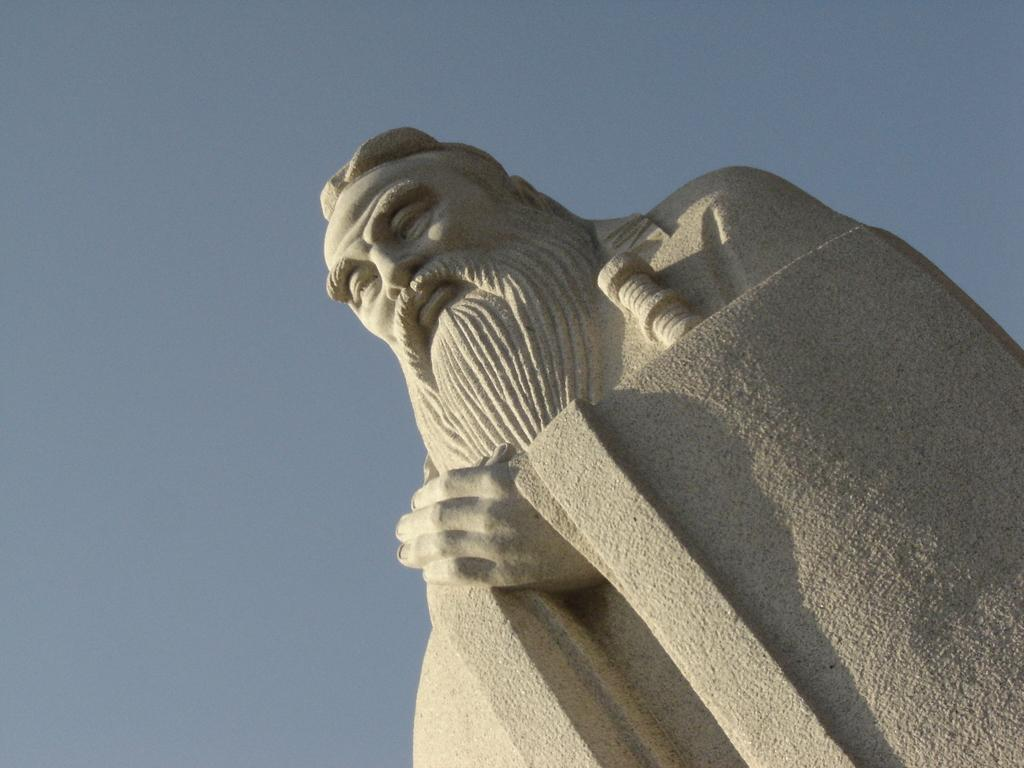What is the main subject of the image? There is a statue of a person in the image. What can be seen in the background of the image? The sky is visible at the top of the image. What type of liquid can be seen flowing on the street in the image? There is no street or liquid present in the image; it only features a statue and the sky. 